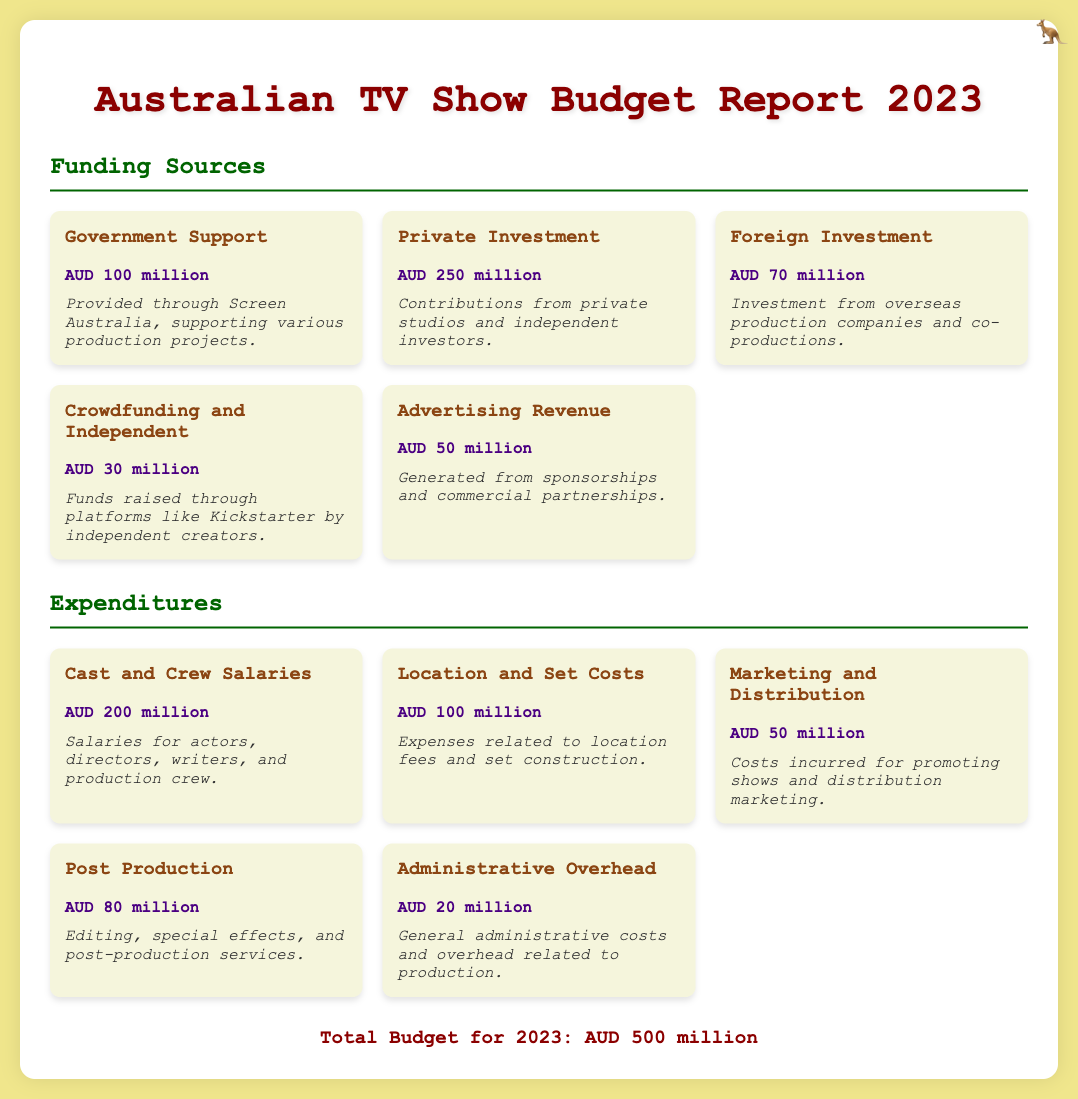what is the total budget for 2023? The total budget for 2023 is clearly stated in the document as the summarized figure of all funding sources and expenditures.
Answer: AUD 500 million how much funding comes from Government Support? The funding source labeled as Government Support provides a clear monetary amount in the document.
Answer: AUD 100 million what is the expenditure for Cast and Crew Salaries? The expenditure category for Cast and Crew Salaries is listed with a precise number in the expenditures section.
Answer: AUD 200 million which funding source has the highest amount? By comparing all funding sources, we determine that Private Investment has the highest allocated amount.
Answer: AUD 250 million how much funding is generated from Advertising Revenue? The document specifies the amount listed under Advertising Revenue, providing a straightforward answer.
Answer: AUD 50 million what is the total amount of Crowdfunding and Independent funds? The amount of Crowdfunding and Independent is specified and can be directly quoted from the funding sources section.
Answer: AUD 30 million how much is allocated for Post Production? The expenditure on Post Production is mentioned directly in the report under expenditures.
Answer: AUD 80 million which source of funding involves investment from overseas? The specific funding source that involves overseas investments is explicitly named in the funding section.
Answer: Foreign Investment what category has the lowest expenditure? By reviewing all expenditure categories, we find the one with the lowest budget allocation as mentioned in the document.
Answer: Administrative Overhead 